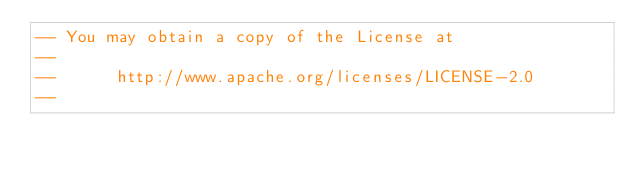Convert code to text. <code><loc_0><loc_0><loc_500><loc_500><_SQL_>-- You may obtain a copy of the License at
-- 
--      http://www.apache.org/licenses/LICENSE-2.0
-- </code> 